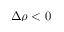<formula> <loc_0><loc_0><loc_500><loc_500>\Delta \rho < 0</formula> 